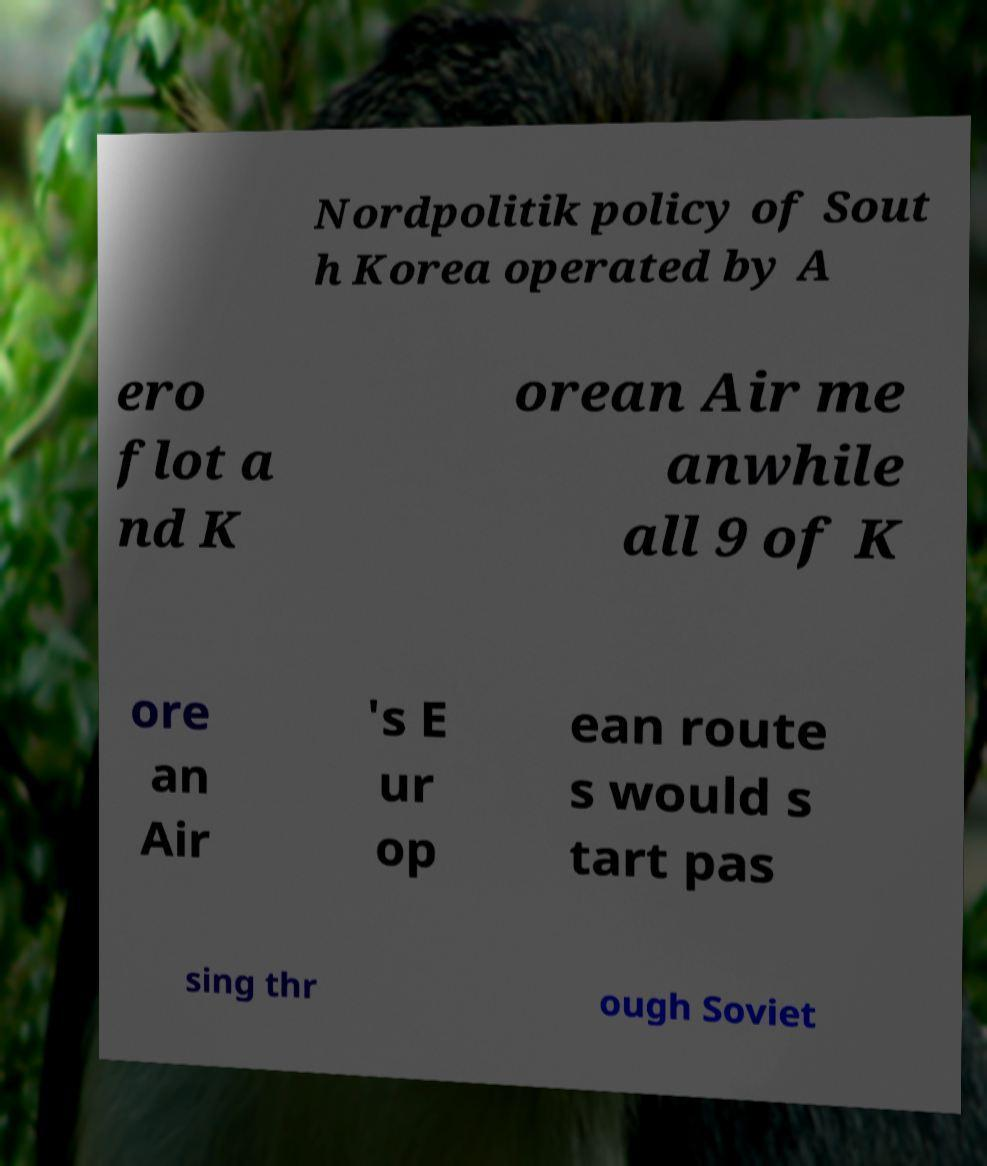Could you extract and type out the text from this image? Nordpolitik policy of Sout h Korea operated by A ero flot a nd K orean Air me anwhile all 9 of K ore an Air 's E ur op ean route s would s tart pas sing thr ough Soviet 